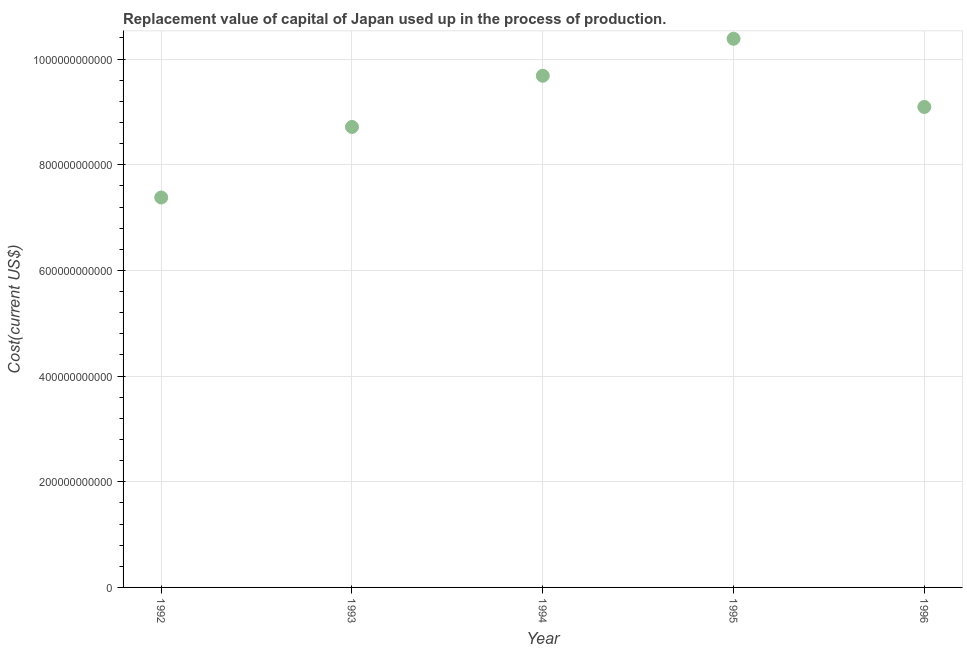What is the consumption of fixed capital in 1994?
Your response must be concise. 9.68e+11. Across all years, what is the maximum consumption of fixed capital?
Your response must be concise. 1.04e+12. Across all years, what is the minimum consumption of fixed capital?
Offer a terse response. 7.38e+11. In which year was the consumption of fixed capital minimum?
Offer a very short reply. 1992. What is the sum of the consumption of fixed capital?
Provide a succinct answer. 4.53e+12. What is the difference between the consumption of fixed capital in 1993 and 1996?
Your response must be concise. -3.78e+1. What is the average consumption of fixed capital per year?
Provide a short and direct response. 9.05e+11. What is the median consumption of fixed capital?
Ensure brevity in your answer.  9.09e+11. What is the ratio of the consumption of fixed capital in 1994 to that in 1996?
Your response must be concise. 1.06. Is the consumption of fixed capital in 1994 less than that in 1996?
Your answer should be very brief. No. What is the difference between the highest and the second highest consumption of fixed capital?
Your answer should be compact. 7.00e+1. Is the sum of the consumption of fixed capital in 1993 and 1995 greater than the maximum consumption of fixed capital across all years?
Your answer should be very brief. Yes. What is the difference between the highest and the lowest consumption of fixed capital?
Provide a short and direct response. 3.00e+11. In how many years, is the consumption of fixed capital greater than the average consumption of fixed capital taken over all years?
Your answer should be compact. 3. Does the consumption of fixed capital monotonically increase over the years?
Make the answer very short. No. What is the difference between two consecutive major ticks on the Y-axis?
Give a very brief answer. 2.00e+11. Does the graph contain grids?
Provide a short and direct response. Yes. What is the title of the graph?
Provide a succinct answer. Replacement value of capital of Japan used up in the process of production. What is the label or title of the Y-axis?
Provide a succinct answer. Cost(current US$). What is the Cost(current US$) in 1992?
Offer a very short reply. 7.38e+11. What is the Cost(current US$) in 1993?
Make the answer very short. 8.72e+11. What is the Cost(current US$) in 1994?
Offer a terse response. 9.68e+11. What is the Cost(current US$) in 1995?
Offer a very short reply. 1.04e+12. What is the Cost(current US$) in 1996?
Give a very brief answer. 9.09e+11. What is the difference between the Cost(current US$) in 1992 and 1993?
Ensure brevity in your answer.  -1.34e+11. What is the difference between the Cost(current US$) in 1992 and 1994?
Your answer should be very brief. -2.30e+11. What is the difference between the Cost(current US$) in 1992 and 1995?
Offer a terse response. -3.00e+11. What is the difference between the Cost(current US$) in 1992 and 1996?
Keep it short and to the point. -1.71e+11. What is the difference between the Cost(current US$) in 1993 and 1994?
Provide a succinct answer. -9.69e+1. What is the difference between the Cost(current US$) in 1993 and 1995?
Keep it short and to the point. -1.67e+11. What is the difference between the Cost(current US$) in 1993 and 1996?
Provide a succinct answer. -3.78e+1. What is the difference between the Cost(current US$) in 1994 and 1995?
Make the answer very short. -7.00e+1. What is the difference between the Cost(current US$) in 1994 and 1996?
Your answer should be compact. 5.91e+1. What is the difference between the Cost(current US$) in 1995 and 1996?
Provide a succinct answer. 1.29e+11. What is the ratio of the Cost(current US$) in 1992 to that in 1993?
Offer a very short reply. 0.85. What is the ratio of the Cost(current US$) in 1992 to that in 1994?
Keep it short and to the point. 0.76. What is the ratio of the Cost(current US$) in 1992 to that in 1995?
Provide a succinct answer. 0.71. What is the ratio of the Cost(current US$) in 1992 to that in 1996?
Provide a short and direct response. 0.81. What is the ratio of the Cost(current US$) in 1993 to that in 1995?
Your response must be concise. 0.84. What is the ratio of the Cost(current US$) in 1993 to that in 1996?
Provide a succinct answer. 0.96. What is the ratio of the Cost(current US$) in 1994 to that in 1995?
Your answer should be very brief. 0.93. What is the ratio of the Cost(current US$) in 1994 to that in 1996?
Make the answer very short. 1.06. What is the ratio of the Cost(current US$) in 1995 to that in 1996?
Give a very brief answer. 1.14. 